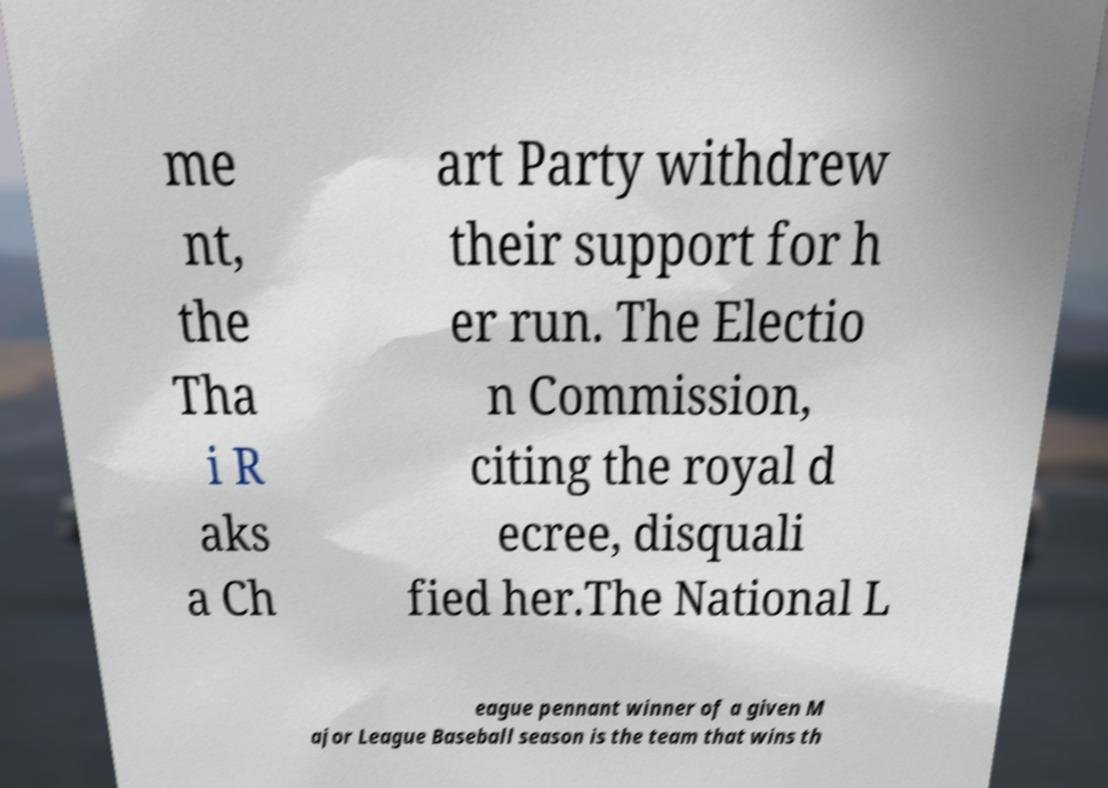Please read and relay the text visible in this image. What does it say? me nt, the Tha i R aks a Ch art Party withdrew their support for h er run. The Electio n Commission, citing the royal d ecree, disquali fied her.The National L eague pennant winner of a given M ajor League Baseball season is the team that wins th 